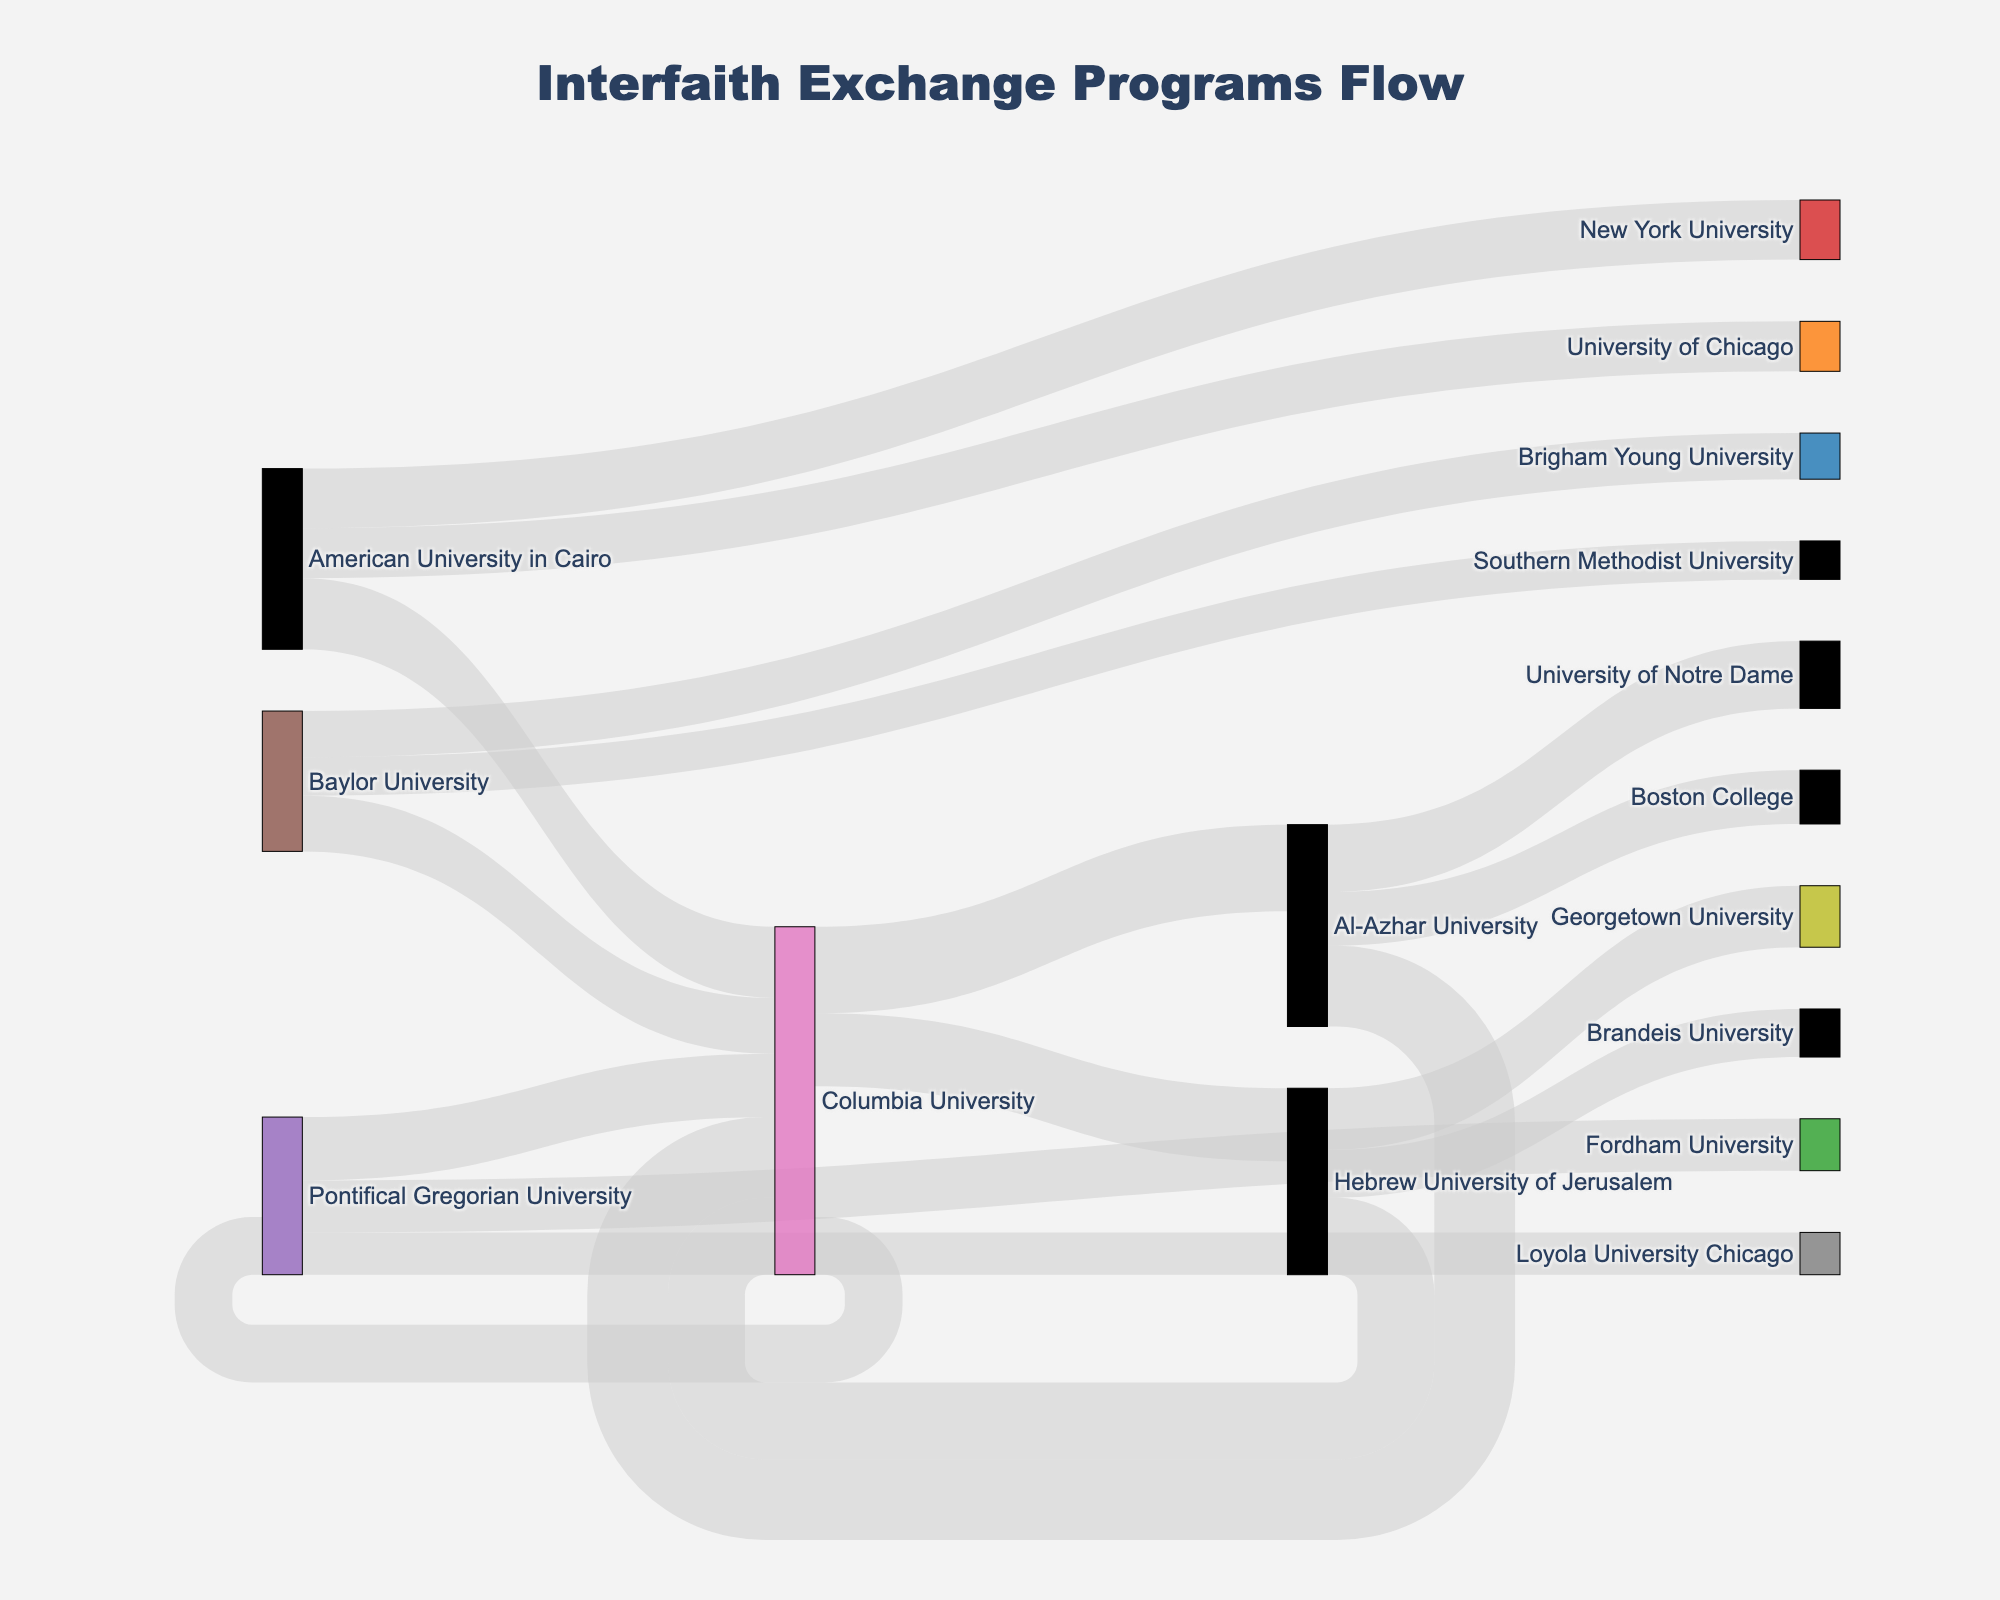What's the highest number of students exchanged between any two universities? Look at each linking line between universities representing the number of students exchanged; the highest value is 45 between Columbia University and Al-Azhar University.
Answer: 45 Which university is involved in exchanges with the most other universities? Count the number of distinct universities connected to each university. For Columbia University: 5, Al-Azhar University: 4, Hebrew University of Jerusalem: 3, Pontifical Gregorian University: 3, American University in Cairo: 3, Baylor University: 3. Columbia University has the most connections.
Answer: Columbia University How many students in total are exchanged to Columbia University? Sum the values of all incoming flows to Columbia University: 42 (from Al-Azhar University) + 40 (from Hebrew University of Jerusalem) + 33 (from Pontifical Gregorian University) + 37 (from American University in Cairo) + 29 (from Baylor University) = 181.
Answer: 181 Compare the number of students exchanged between Columbia University and Al-Azhar University, and Columbia University and Hebrew University of Jerusalem. Which pair has more students exchanged? Columbia University and Al-Azhar University have 45 students exchanged. Columbia University and Hebrew University of Jerusalem have 38 students exchanged. 45 is greater than 38.
Answer: Columbia University and Al-Azhar University What's the combined total number of students exchanged between Columbia University and the three universities it exchanges with the least number of students? Identify the least exchanges: 30 (Pontifical Gregorian University), 38 (Hebrew University of Jerusalem), 45 (Al-Azhar University). Calculate the total: 30 + 38 + 45 = 113.
Answer: 113 Which university has the smallest outgoing flow to other universities, and what is that flow? Check the flow values for each university. The smallest outgoing flow is from Baylor University, with values of 29, 24, and 20. The total is 73, which is the smallest among all.
Answer: Baylor University, 73 Which university received the second-highest number of students from other universities? First, find the total incoming students for each university. After calculating the totals, the second highest is American University in Cairo: 37 (from Columbia University) + 31 (from New York University) + 26 (from University of Chicago) = 94.
Answer: American University in Cairo What is the total number of students exchanged in the entire network? Sum all the values: 45+38+30+42+35+28+40+32+25+33+27+22+37+31+26+29+24+20 = 564.
Answer: 564 Which university sends more students to Columbia University: Hebrew University of Jerusalem or Al-Azhar University? Compare the linked values. Hebrew University of Jerusalem sends 40 students, while Al-Azhar University sends 42 students.
Answer: Al-Azhar University How many more students does Columbia University send to Al-Azhar University compared to Pontifical Gregorian University? Columbia University sends 45 students to Al-Azhar University and 30 to Pontifical Gregorian. The difference is 45 - 30 = 15.
Answer: 15 